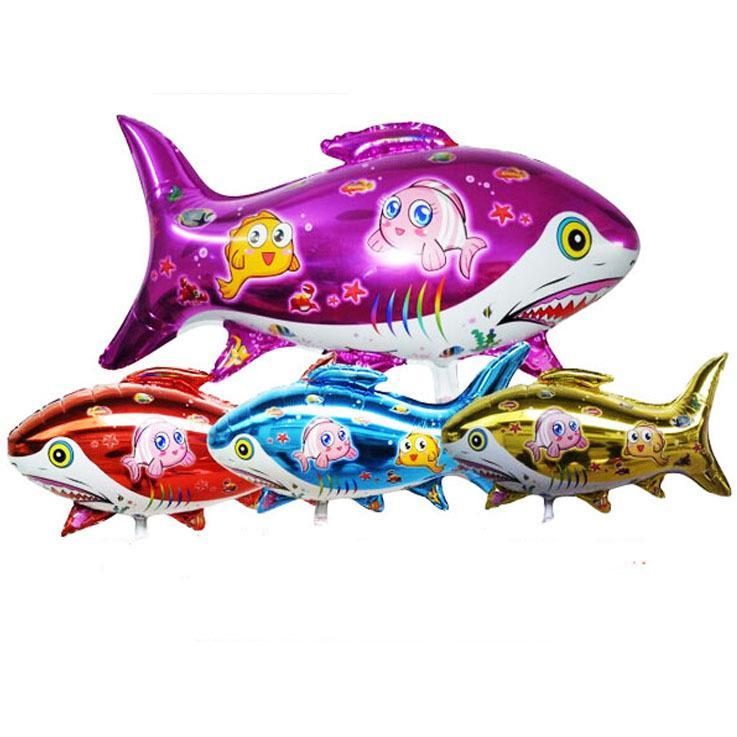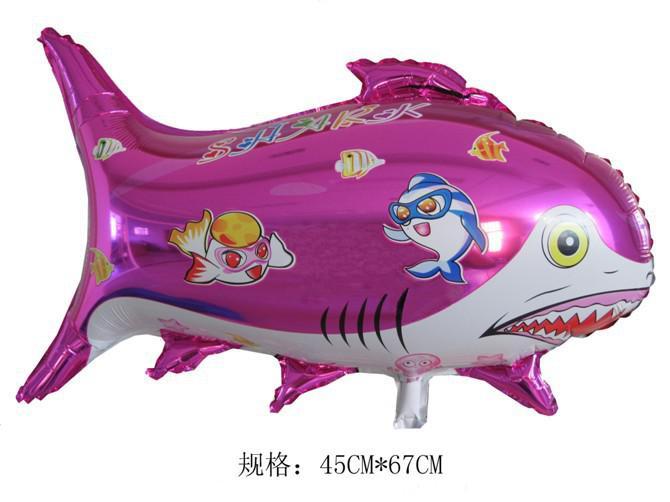The first image is the image on the left, the second image is the image on the right. For the images displayed, is the sentence "There are no less than five balloons" factually correct? Answer yes or no. Yes. 